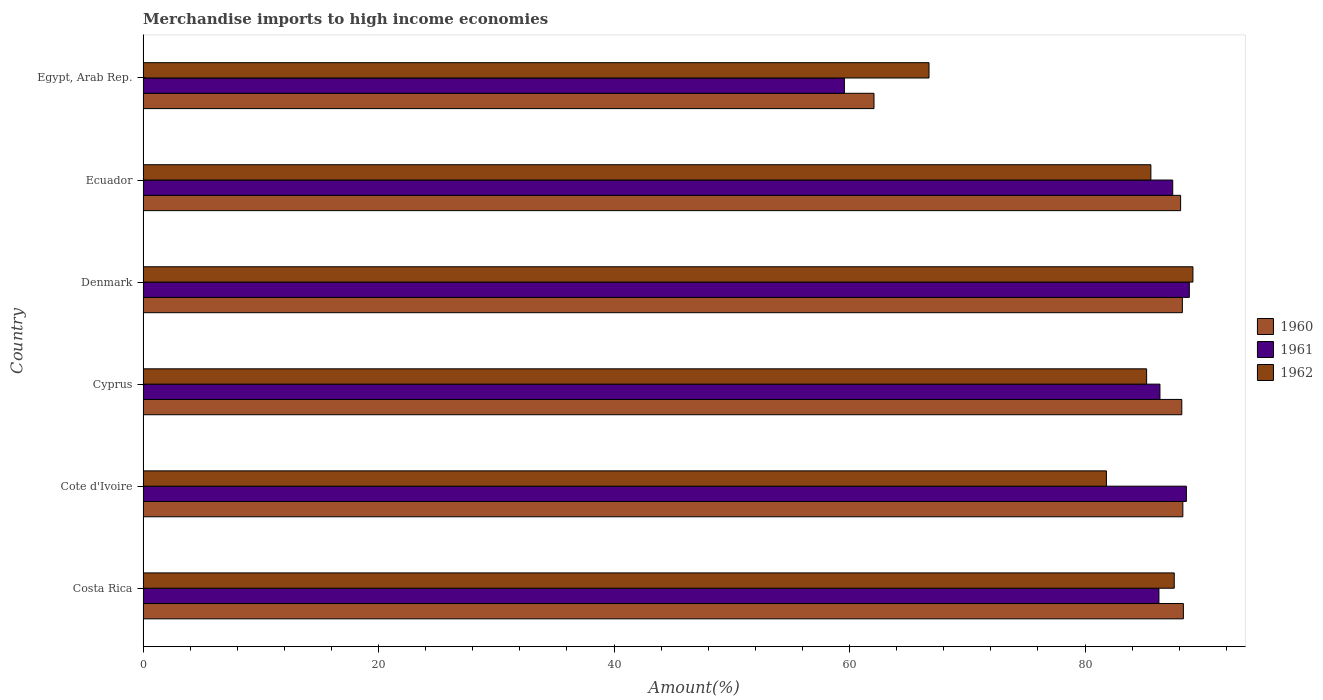How many different coloured bars are there?
Give a very brief answer. 3. Are the number of bars per tick equal to the number of legend labels?
Make the answer very short. Yes. How many bars are there on the 6th tick from the top?
Provide a short and direct response. 3. What is the label of the 2nd group of bars from the top?
Your answer should be very brief. Ecuador. What is the percentage of amount earned from merchandise imports in 1961 in Cyprus?
Your response must be concise. 86.36. Across all countries, what is the maximum percentage of amount earned from merchandise imports in 1960?
Your answer should be very brief. 88.35. Across all countries, what is the minimum percentage of amount earned from merchandise imports in 1962?
Offer a very short reply. 66.75. In which country was the percentage of amount earned from merchandise imports in 1961 minimum?
Keep it short and to the point. Egypt, Arab Rep. What is the total percentage of amount earned from merchandise imports in 1961 in the graph?
Provide a succinct answer. 497.12. What is the difference between the percentage of amount earned from merchandise imports in 1960 in Cote d'Ivoire and that in Denmark?
Offer a terse response. 0.04. What is the difference between the percentage of amount earned from merchandise imports in 1962 in Cote d'Ivoire and the percentage of amount earned from merchandise imports in 1960 in Cyprus?
Provide a short and direct response. -6.4. What is the average percentage of amount earned from merchandise imports in 1960 per country?
Offer a terse response. 83.89. What is the difference between the percentage of amount earned from merchandise imports in 1962 and percentage of amount earned from merchandise imports in 1961 in Egypt, Arab Rep.?
Your answer should be very brief. 7.19. In how many countries, is the percentage of amount earned from merchandise imports in 1962 greater than 72 %?
Provide a succinct answer. 5. What is the ratio of the percentage of amount earned from merchandise imports in 1960 in Denmark to that in Egypt, Arab Rep.?
Make the answer very short. 1.42. Is the difference between the percentage of amount earned from merchandise imports in 1962 in Cyprus and Ecuador greater than the difference between the percentage of amount earned from merchandise imports in 1961 in Cyprus and Ecuador?
Your answer should be very brief. Yes. What is the difference between the highest and the second highest percentage of amount earned from merchandise imports in 1960?
Make the answer very short. 0.04. What is the difference between the highest and the lowest percentage of amount earned from merchandise imports in 1962?
Provide a short and direct response. 22.42. What does the 1st bar from the bottom in Denmark represents?
Keep it short and to the point. 1960. How many bars are there?
Provide a succinct answer. 18. How many countries are there in the graph?
Give a very brief answer. 6. Where does the legend appear in the graph?
Provide a short and direct response. Center right. How many legend labels are there?
Offer a very short reply. 3. How are the legend labels stacked?
Offer a very short reply. Vertical. What is the title of the graph?
Your answer should be very brief. Merchandise imports to high income economies. Does "2014" appear as one of the legend labels in the graph?
Ensure brevity in your answer.  No. What is the label or title of the X-axis?
Make the answer very short. Amount(%). What is the Amount(%) of 1960 in Costa Rica?
Your response must be concise. 88.35. What is the Amount(%) in 1961 in Costa Rica?
Your answer should be compact. 86.28. What is the Amount(%) of 1962 in Costa Rica?
Offer a terse response. 87.58. What is the Amount(%) in 1960 in Cote d'Ivoire?
Your answer should be very brief. 88.31. What is the Amount(%) of 1961 in Cote d'Ivoire?
Provide a succinct answer. 88.61. What is the Amount(%) in 1962 in Cote d'Ivoire?
Your answer should be very brief. 81.82. What is the Amount(%) in 1960 in Cyprus?
Give a very brief answer. 88.22. What is the Amount(%) of 1961 in Cyprus?
Provide a short and direct response. 86.36. What is the Amount(%) in 1962 in Cyprus?
Keep it short and to the point. 85.23. What is the Amount(%) of 1960 in Denmark?
Make the answer very short. 88.27. What is the Amount(%) in 1961 in Denmark?
Your response must be concise. 88.86. What is the Amount(%) in 1962 in Denmark?
Your answer should be compact. 89.17. What is the Amount(%) of 1960 in Ecuador?
Offer a terse response. 88.12. What is the Amount(%) in 1961 in Ecuador?
Offer a very short reply. 87.45. What is the Amount(%) in 1962 in Ecuador?
Ensure brevity in your answer.  85.59. What is the Amount(%) in 1960 in Egypt, Arab Rep.?
Your answer should be compact. 62.08. What is the Amount(%) in 1961 in Egypt, Arab Rep.?
Make the answer very short. 59.56. What is the Amount(%) of 1962 in Egypt, Arab Rep.?
Your answer should be very brief. 66.75. Across all countries, what is the maximum Amount(%) of 1960?
Make the answer very short. 88.35. Across all countries, what is the maximum Amount(%) in 1961?
Provide a succinct answer. 88.86. Across all countries, what is the maximum Amount(%) of 1962?
Provide a short and direct response. 89.17. Across all countries, what is the minimum Amount(%) in 1960?
Make the answer very short. 62.08. Across all countries, what is the minimum Amount(%) in 1961?
Your response must be concise. 59.56. Across all countries, what is the minimum Amount(%) of 1962?
Ensure brevity in your answer.  66.75. What is the total Amount(%) in 1960 in the graph?
Provide a short and direct response. 503.35. What is the total Amount(%) of 1961 in the graph?
Make the answer very short. 497.12. What is the total Amount(%) in 1962 in the graph?
Keep it short and to the point. 496.14. What is the difference between the Amount(%) of 1960 in Costa Rica and that in Cote d'Ivoire?
Make the answer very short. 0.04. What is the difference between the Amount(%) of 1961 in Costa Rica and that in Cote d'Ivoire?
Your response must be concise. -2.33. What is the difference between the Amount(%) in 1962 in Costa Rica and that in Cote d'Ivoire?
Keep it short and to the point. 5.76. What is the difference between the Amount(%) in 1960 in Costa Rica and that in Cyprus?
Provide a short and direct response. 0.13. What is the difference between the Amount(%) of 1961 in Costa Rica and that in Cyprus?
Keep it short and to the point. -0.09. What is the difference between the Amount(%) in 1962 in Costa Rica and that in Cyprus?
Make the answer very short. 2.35. What is the difference between the Amount(%) in 1960 in Costa Rica and that in Denmark?
Your answer should be very brief. 0.09. What is the difference between the Amount(%) in 1961 in Costa Rica and that in Denmark?
Your response must be concise. -2.58. What is the difference between the Amount(%) of 1962 in Costa Rica and that in Denmark?
Provide a succinct answer. -1.59. What is the difference between the Amount(%) in 1960 in Costa Rica and that in Ecuador?
Make the answer very short. 0.23. What is the difference between the Amount(%) in 1961 in Costa Rica and that in Ecuador?
Offer a terse response. -1.17. What is the difference between the Amount(%) of 1962 in Costa Rica and that in Ecuador?
Your response must be concise. 1.99. What is the difference between the Amount(%) in 1960 in Costa Rica and that in Egypt, Arab Rep.?
Your answer should be very brief. 26.27. What is the difference between the Amount(%) in 1961 in Costa Rica and that in Egypt, Arab Rep.?
Provide a succinct answer. 26.71. What is the difference between the Amount(%) in 1962 in Costa Rica and that in Egypt, Arab Rep.?
Your response must be concise. 20.83. What is the difference between the Amount(%) in 1960 in Cote d'Ivoire and that in Cyprus?
Keep it short and to the point. 0.09. What is the difference between the Amount(%) in 1961 in Cote d'Ivoire and that in Cyprus?
Your answer should be compact. 2.25. What is the difference between the Amount(%) of 1962 in Cote d'Ivoire and that in Cyprus?
Give a very brief answer. -3.41. What is the difference between the Amount(%) of 1960 in Cote d'Ivoire and that in Denmark?
Ensure brevity in your answer.  0.04. What is the difference between the Amount(%) in 1961 in Cote d'Ivoire and that in Denmark?
Your answer should be very brief. -0.25. What is the difference between the Amount(%) of 1962 in Cote d'Ivoire and that in Denmark?
Provide a short and direct response. -7.35. What is the difference between the Amount(%) in 1960 in Cote d'Ivoire and that in Ecuador?
Provide a short and direct response. 0.19. What is the difference between the Amount(%) in 1961 in Cote d'Ivoire and that in Ecuador?
Ensure brevity in your answer.  1.16. What is the difference between the Amount(%) in 1962 in Cote d'Ivoire and that in Ecuador?
Provide a short and direct response. -3.77. What is the difference between the Amount(%) in 1960 in Cote d'Ivoire and that in Egypt, Arab Rep.?
Your answer should be compact. 26.23. What is the difference between the Amount(%) in 1961 in Cote d'Ivoire and that in Egypt, Arab Rep.?
Provide a succinct answer. 29.05. What is the difference between the Amount(%) of 1962 in Cote d'Ivoire and that in Egypt, Arab Rep.?
Provide a short and direct response. 15.07. What is the difference between the Amount(%) in 1960 in Cyprus and that in Denmark?
Keep it short and to the point. -0.05. What is the difference between the Amount(%) in 1961 in Cyprus and that in Denmark?
Your answer should be compact. -2.49. What is the difference between the Amount(%) of 1962 in Cyprus and that in Denmark?
Give a very brief answer. -3.93. What is the difference between the Amount(%) in 1960 in Cyprus and that in Ecuador?
Provide a short and direct response. 0.1. What is the difference between the Amount(%) of 1961 in Cyprus and that in Ecuador?
Your response must be concise. -1.09. What is the difference between the Amount(%) in 1962 in Cyprus and that in Ecuador?
Offer a terse response. -0.36. What is the difference between the Amount(%) of 1960 in Cyprus and that in Egypt, Arab Rep.?
Provide a succinct answer. 26.14. What is the difference between the Amount(%) in 1961 in Cyprus and that in Egypt, Arab Rep.?
Keep it short and to the point. 26.8. What is the difference between the Amount(%) of 1962 in Cyprus and that in Egypt, Arab Rep.?
Offer a very short reply. 18.48. What is the difference between the Amount(%) of 1960 in Denmark and that in Ecuador?
Ensure brevity in your answer.  0.15. What is the difference between the Amount(%) in 1961 in Denmark and that in Ecuador?
Offer a terse response. 1.41. What is the difference between the Amount(%) of 1962 in Denmark and that in Ecuador?
Your response must be concise. 3.57. What is the difference between the Amount(%) in 1960 in Denmark and that in Egypt, Arab Rep.?
Ensure brevity in your answer.  26.19. What is the difference between the Amount(%) in 1961 in Denmark and that in Egypt, Arab Rep.?
Offer a terse response. 29.29. What is the difference between the Amount(%) of 1962 in Denmark and that in Egypt, Arab Rep.?
Your answer should be very brief. 22.42. What is the difference between the Amount(%) of 1960 in Ecuador and that in Egypt, Arab Rep.?
Give a very brief answer. 26.04. What is the difference between the Amount(%) in 1961 in Ecuador and that in Egypt, Arab Rep.?
Offer a terse response. 27.89. What is the difference between the Amount(%) of 1962 in Ecuador and that in Egypt, Arab Rep.?
Offer a very short reply. 18.84. What is the difference between the Amount(%) of 1960 in Costa Rica and the Amount(%) of 1961 in Cote d'Ivoire?
Your answer should be compact. -0.26. What is the difference between the Amount(%) in 1960 in Costa Rica and the Amount(%) in 1962 in Cote d'Ivoire?
Your response must be concise. 6.53. What is the difference between the Amount(%) in 1961 in Costa Rica and the Amount(%) in 1962 in Cote d'Ivoire?
Keep it short and to the point. 4.46. What is the difference between the Amount(%) in 1960 in Costa Rica and the Amount(%) in 1961 in Cyprus?
Provide a succinct answer. 1.99. What is the difference between the Amount(%) of 1960 in Costa Rica and the Amount(%) of 1962 in Cyprus?
Make the answer very short. 3.12. What is the difference between the Amount(%) of 1961 in Costa Rica and the Amount(%) of 1962 in Cyprus?
Keep it short and to the point. 1.05. What is the difference between the Amount(%) of 1960 in Costa Rica and the Amount(%) of 1961 in Denmark?
Ensure brevity in your answer.  -0.51. What is the difference between the Amount(%) of 1960 in Costa Rica and the Amount(%) of 1962 in Denmark?
Your answer should be compact. -0.81. What is the difference between the Amount(%) of 1961 in Costa Rica and the Amount(%) of 1962 in Denmark?
Offer a terse response. -2.89. What is the difference between the Amount(%) of 1960 in Costa Rica and the Amount(%) of 1961 in Ecuador?
Provide a succinct answer. 0.9. What is the difference between the Amount(%) of 1960 in Costa Rica and the Amount(%) of 1962 in Ecuador?
Offer a very short reply. 2.76. What is the difference between the Amount(%) of 1961 in Costa Rica and the Amount(%) of 1962 in Ecuador?
Provide a short and direct response. 0.69. What is the difference between the Amount(%) in 1960 in Costa Rica and the Amount(%) in 1961 in Egypt, Arab Rep.?
Your answer should be very brief. 28.79. What is the difference between the Amount(%) in 1960 in Costa Rica and the Amount(%) in 1962 in Egypt, Arab Rep.?
Your answer should be very brief. 21.6. What is the difference between the Amount(%) of 1961 in Costa Rica and the Amount(%) of 1962 in Egypt, Arab Rep.?
Ensure brevity in your answer.  19.53. What is the difference between the Amount(%) of 1960 in Cote d'Ivoire and the Amount(%) of 1961 in Cyprus?
Offer a very short reply. 1.95. What is the difference between the Amount(%) in 1960 in Cote d'Ivoire and the Amount(%) in 1962 in Cyprus?
Offer a terse response. 3.08. What is the difference between the Amount(%) of 1961 in Cote d'Ivoire and the Amount(%) of 1962 in Cyprus?
Your response must be concise. 3.38. What is the difference between the Amount(%) in 1960 in Cote d'Ivoire and the Amount(%) in 1961 in Denmark?
Offer a very short reply. -0.55. What is the difference between the Amount(%) in 1960 in Cote d'Ivoire and the Amount(%) in 1962 in Denmark?
Your answer should be very brief. -0.86. What is the difference between the Amount(%) of 1961 in Cote d'Ivoire and the Amount(%) of 1962 in Denmark?
Keep it short and to the point. -0.56. What is the difference between the Amount(%) in 1960 in Cote d'Ivoire and the Amount(%) in 1961 in Ecuador?
Your answer should be compact. 0.86. What is the difference between the Amount(%) in 1960 in Cote d'Ivoire and the Amount(%) in 1962 in Ecuador?
Keep it short and to the point. 2.72. What is the difference between the Amount(%) in 1961 in Cote d'Ivoire and the Amount(%) in 1962 in Ecuador?
Your response must be concise. 3.02. What is the difference between the Amount(%) of 1960 in Cote d'Ivoire and the Amount(%) of 1961 in Egypt, Arab Rep.?
Your answer should be very brief. 28.75. What is the difference between the Amount(%) of 1960 in Cote d'Ivoire and the Amount(%) of 1962 in Egypt, Arab Rep.?
Provide a short and direct response. 21.56. What is the difference between the Amount(%) in 1961 in Cote d'Ivoire and the Amount(%) in 1962 in Egypt, Arab Rep.?
Give a very brief answer. 21.86. What is the difference between the Amount(%) in 1960 in Cyprus and the Amount(%) in 1961 in Denmark?
Offer a very short reply. -0.64. What is the difference between the Amount(%) in 1960 in Cyprus and the Amount(%) in 1962 in Denmark?
Provide a succinct answer. -0.95. What is the difference between the Amount(%) of 1961 in Cyprus and the Amount(%) of 1962 in Denmark?
Make the answer very short. -2.8. What is the difference between the Amount(%) in 1960 in Cyprus and the Amount(%) in 1961 in Ecuador?
Give a very brief answer. 0.77. What is the difference between the Amount(%) of 1960 in Cyprus and the Amount(%) of 1962 in Ecuador?
Offer a terse response. 2.63. What is the difference between the Amount(%) of 1961 in Cyprus and the Amount(%) of 1962 in Ecuador?
Your answer should be compact. 0.77. What is the difference between the Amount(%) in 1960 in Cyprus and the Amount(%) in 1961 in Egypt, Arab Rep.?
Offer a terse response. 28.66. What is the difference between the Amount(%) of 1960 in Cyprus and the Amount(%) of 1962 in Egypt, Arab Rep.?
Give a very brief answer. 21.47. What is the difference between the Amount(%) of 1961 in Cyprus and the Amount(%) of 1962 in Egypt, Arab Rep.?
Your answer should be very brief. 19.61. What is the difference between the Amount(%) in 1960 in Denmark and the Amount(%) in 1961 in Ecuador?
Your answer should be very brief. 0.82. What is the difference between the Amount(%) of 1960 in Denmark and the Amount(%) of 1962 in Ecuador?
Keep it short and to the point. 2.67. What is the difference between the Amount(%) in 1961 in Denmark and the Amount(%) in 1962 in Ecuador?
Ensure brevity in your answer.  3.27. What is the difference between the Amount(%) of 1960 in Denmark and the Amount(%) of 1961 in Egypt, Arab Rep.?
Offer a terse response. 28.7. What is the difference between the Amount(%) in 1960 in Denmark and the Amount(%) in 1962 in Egypt, Arab Rep.?
Provide a succinct answer. 21.52. What is the difference between the Amount(%) in 1961 in Denmark and the Amount(%) in 1962 in Egypt, Arab Rep.?
Provide a succinct answer. 22.11. What is the difference between the Amount(%) of 1960 in Ecuador and the Amount(%) of 1961 in Egypt, Arab Rep.?
Ensure brevity in your answer.  28.56. What is the difference between the Amount(%) in 1960 in Ecuador and the Amount(%) in 1962 in Egypt, Arab Rep.?
Make the answer very short. 21.37. What is the difference between the Amount(%) in 1961 in Ecuador and the Amount(%) in 1962 in Egypt, Arab Rep.?
Ensure brevity in your answer.  20.7. What is the average Amount(%) of 1960 per country?
Make the answer very short. 83.89. What is the average Amount(%) of 1961 per country?
Ensure brevity in your answer.  82.85. What is the average Amount(%) of 1962 per country?
Make the answer very short. 82.69. What is the difference between the Amount(%) in 1960 and Amount(%) in 1961 in Costa Rica?
Give a very brief answer. 2.07. What is the difference between the Amount(%) of 1960 and Amount(%) of 1962 in Costa Rica?
Your answer should be compact. 0.77. What is the difference between the Amount(%) of 1961 and Amount(%) of 1962 in Costa Rica?
Your answer should be compact. -1.3. What is the difference between the Amount(%) of 1960 and Amount(%) of 1961 in Cote d'Ivoire?
Offer a very short reply. -0.3. What is the difference between the Amount(%) of 1960 and Amount(%) of 1962 in Cote d'Ivoire?
Make the answer very short. 6.49. What is the difference between the Amount(%) of 1961 and Amount(%) of 1962 in Cote d'Ivoire?
Your answer should be very brief. 6.79. What is the difference between the Amount(%) in 1960 and Amount(%) in 1961 in Cyprus?
Your response must be concise. 1.86. What is the difference between the Amount(%) of 1960 and Amount(%) of 1962 in Cyprus?
Your response must be concise. 2.99. What is the difference between the Amount(%) in 1961 and Amount(%) in 1962 in Cyprus?
Offer a very short reply. 1.13. What is the difference between the Amount(%) of 1960 and Amount(%) of 1961 in Denmark?
Your response must be concise. -0.59. What is the difference between the Amount(%) of 1960 and Amount(%) of 1962 in Denmark?
Make the answer very short. -0.9. What is the difference between the Amount(%) in 1961 and Amount(%) in 1962 in Denmark?
Keep it short and to the point. -0.31. What is the difference between the Amount(%) of 1960 and Amount(%) of 1961 in Ecuador?
Provide a short and direct response. 0.67. What is the difference between the Amount(%) in 1960 and Amount(%) in 1962 in Ecuador?
Give a very brief answer. 2.53. What is the difference between the Amount(%) of 1961 and Amount(%) of 1962 in Ecuador?
Ensure brevity in your answer.  1.86. What is the difference between the Amount(%) in 1960 and Amount(%) in 1961 in Egypt, Arab Rep.?
Your answer should be compact. 2.51. What is the difference between the Amount(%) of 1960 and Amount(%) of 1962 in Egypt, Arab Rep.?
Your response must be concise. -4.67. What is the difference between the Amount(%) of 1961 and Amount(%) of 1962 in Egypt, Arab Rep.?
Your answer should be very brief. -7.19. What is the ratio of the Amount(%) of 1960 in Costa Rica to that in Cote d'Ivoire?
Make the answer very short. 1. What is the ratio of the Amount(%) in 1961 in Costa Rica to that in Cote d'Ivoire?
Your response must be concise. 0.97. What is the ratio of the Amount(%) in 1962 in Costa Rica to that in Cote d'Ivoire?
Your answer should be very brief. 1.07. What is the ratio of the Amount(%) of 1961 in Costa Rica to that in Cyprus?
Ensure brevity in your answer.  1. What is the ratio of the Amount(%) of 1962 in Costa Rica to that in Cyprus?
Make the answer very short. 1.03. What is the ratio of the Amount(%) in 1960 in Costa Rica to that in Denmark?
Offer a terse response. 1. What is the ratio of the Amount(%) of 1962 in Costa Rica to that in Denmark?
Your response must be concise. 0.98. What is the ratio of the Amount(%) of 1960 in Costa Rica to that in Ecuador?
Ensure brevity in your answer.  1. What is the ratio of the Amount(%) of 1961 in Costa Rica to that in Ecuador?
Offer a terse response. 0.99. What is the ratio of the Amount(%) in 1962 in Costa Rica to that in Ecuador?
Your answer should be compact. 1.02. What is the ratio of the Amount(%) in 1960 in Costa Rica to that in Egypt, Arab Rep.?
Offer a terse response. 1.42. What is the ratio of the Amount(%) in 1961 in Costa Rica to that in Egypt, Arab Rep.?
Your response must be concise. 1.45. What is the ratio of the Amount(%) of 1962 in Costa Rica to that in Egypt, Arab Rep.?
Keep it short and to the point. 1.31. What is the ratio of the Amount(%) of 1960 in Cote d'Ivoire to that in Cyprus?
Your answer should be compact. 1. What is the ratio of the Amount(%) of 1962 in Cote d'Ivoire to that in Cyprus?
Ensure brevity in your answer.  0.96. What is the ratio of the Amount(%) in 1960 in Cote d'Ivoire to that in Denmark?
Offer a very short reply. 1. What is the ratio of the Amount(%) of 1962 in Cote d'Ivoire to that in Denmark?
Provide a succinct answer. 0.92. What is the ratio of the Amount(%) in 1960 in Cote d'Ivoire to that in Ecuador?
Offer a very short reply. 1. What is the ratio of the Amount(%) of 1961 in Cote d'Ivoire to that in Ecuador?
Ensure brevity in your answer.  1.01. What is the ratio of the Amount(%) in 1962 in Cote d'Ivoire to that in Ecuador?
Make the answer very short. 0.96. What is the ratio of the Amount(%) of 1960 in Cote d'Ivoire to that in Egypt, Arab Rep.?
Keep it short and to the point. 1.42. What is the ratio of the Amount(%) of 1961 in Cote d'Ivoire to that in Egypt, Arab Rep.?
Your answer should be very brief. 1.49. What is the ratio of the Amount(%) of 1962 in Cote d'Ivoire to that in Egypt, Arab Rep.?
Your answer should be very brief. 1.23. What is the ratio of the Amount(%) in 1961 in Cyprus to that in Denmark?
Your answer should be compact. 0.97. What is the ratio of the Amount(%) in 1962 in Cyprus to that in Denmark?
Offer a very short reply. 0.96. What is the ratio of the Amount(%) in 1961 in Cyprus to that in Ecuador?
Provide a succinct answer. 0.99. What is the ratio of the Amount(%) of 1962 in Cyprus to that in Ecuador?
Offer a terse response. 1. What is the ratio of the Amount(%) in 1960 in Cyprus to that in Egypt, Arab Rep.?
Ensure brevity in your answer.  1.42. What is the ratio of the Amount(%) of 1961 in Cyprus to that in Egypt, Arab Rep.?
Your response must be concise. 1.45. What is the ratio of the Amount(%) in 1962 in Cyprus to that in Egypt, Arab Rep.?
Offer a very short reply. 1.28. What is the ratio of the Amount(%) of 1961 in Denmark to that in Ecuador?
Your answer should be very brief. 1.02. What is the ratio of the Amount(%) of 1962 in Denmark to that in Ecuador?
Give a very brief answer. 1.04. What is the ratio of the Amount(%) of 1960 in Denmark to that in Egypt, Arab Rep.?
Offer a very short reply. 1.42. What is the ratio of the Amount(%) of 1961 in Denmark to that in Egypt, Arab Rep.?
Your response must be concise. 1.49. What is the ratio of the Amount(%) in 1962 in Denmark to that in Egypt, Arab Rep.?
Keep it short and to the point. 1.34. What is the ratio of the Amount(%) of 1960 in Ecuador to that in Egypt, Arab Rep.?
Your answer should be compact. 1.42. What is the ratio of the Amount(%) of 1961 in Ecuador to that in Egypt, Arab Rep.?
Ensure brevity in your answer.  1.47. What is the ratio of the Amount(%) in 1962 in Ecuador to that in Egypt, Arab Rep.?
Keep it short and to the point. 1.28. What is the difference between the highest and the second highest Amount(%) in 1960?
Give a very brief answer. 0.04. What is the difference between the highest and the second highest Amount(%) in 1961?
Make the answer very short. 0.25. What is the difference between the highest and the second highest Amount(%) of 1962?
Keep it short and to the point. 1.59. What is the difference between the highest and the lowest Amount(%) in 1960?
Your answer should be compact. 26.27. What is the difference between the highest and the lowest Amount(%) of 1961?
Your answer should be compact. 29.29. What is the difference between the highest and the lowest Amount(%) in 1962?
Offer a very short reply. 22.42. 